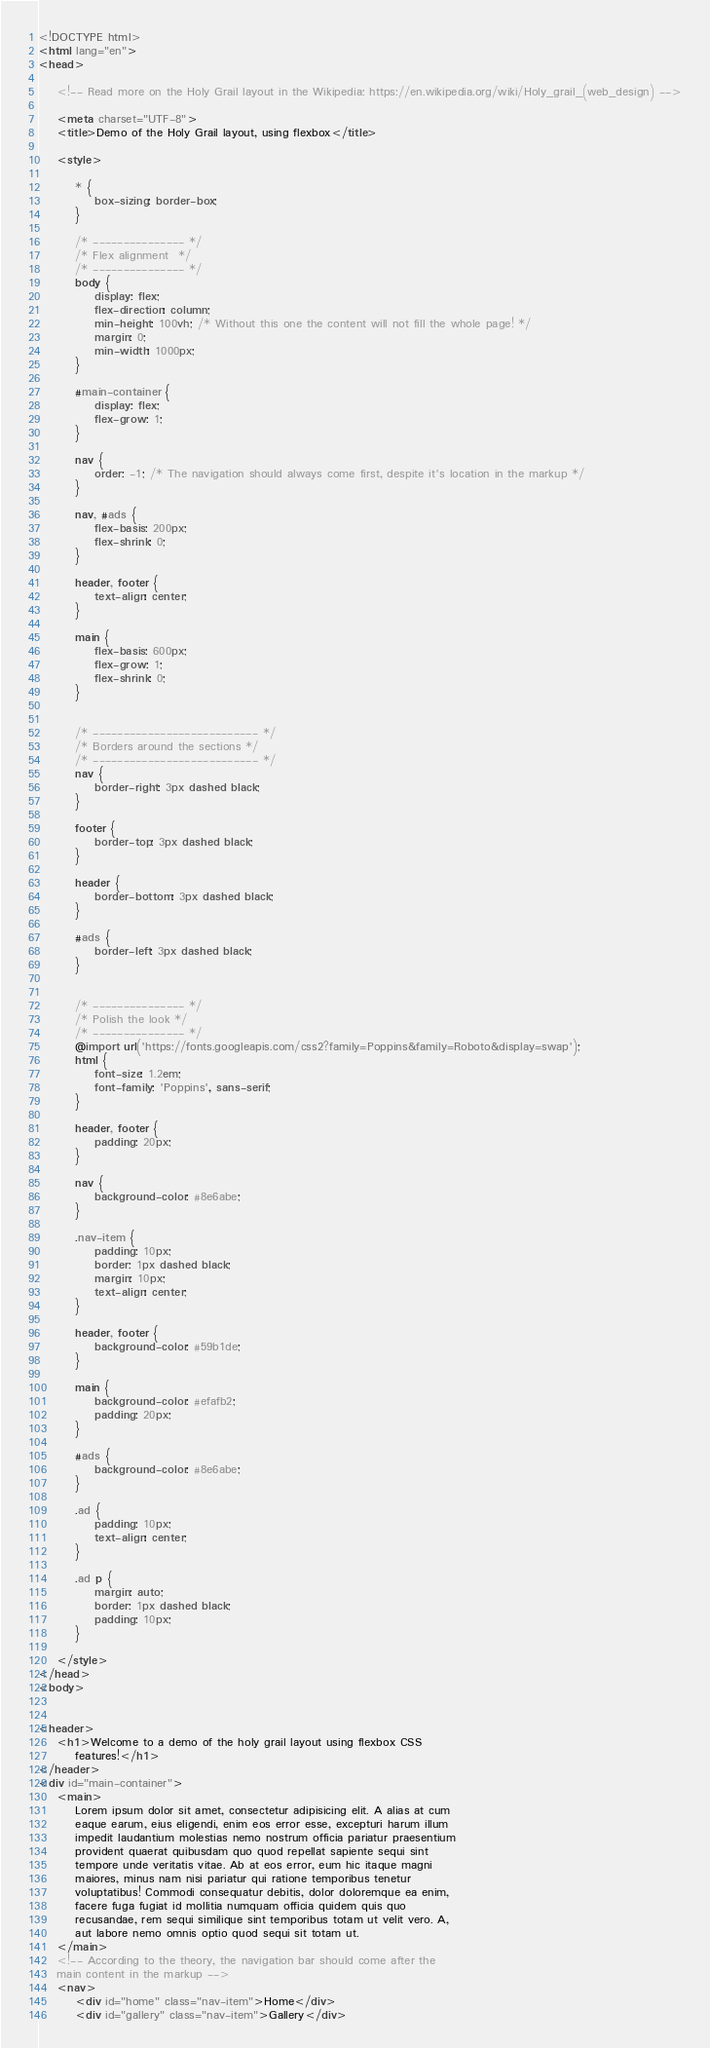Convert code to text. <code><loc_0><loc_0><loc_500><loc_500><_HTML_><!DOCTYPE html>
<html lang="en">
<head>

    <!-- Read more on the Holy Grail layout in the Wikipedia: https://en.wikipedia.org/wiki/Holy_grail_(web_design) -->

    <meta charset="UTF-8">
    <title>Demo of the Holy Grail layout, using flexbox</title>

    <style>

        * {
            box-sizing: border-box;
        }

        /* --------------- */
        /* Flex alignment  */
        /* --------------- */
        body {
            display: flex;
            flex-direction: column;
            min-height: 100vh; /* Without this one the content will not fill the whole page! */
            margin: 0;
            min-width: 1000px;
        }

        #main-container {
            display: flex;
            flex-grow: 1;
        }

        nav {
            order: -1; /* The navigation should always come first, despite it's location in the markup */
        }

        nav, #ads {
            flex-basis: 200px;
            flex-shrink: 0;
        }

        header, footer {
            text-align: center;
        }

        main {
            flex-basis: 600px;
            flex-grow: 1;
            flex-shrink: 0;
        }


        /* --------------------------- */
        /* Borders around the sections */
        /* --------------------------- */
        nav {
            border-right: 3px dashed black;
        }

        footer {
            border-top: 3px dashed black;
        }

        header {
            border-bottom: 3px dashed black;
        }

        #ads {
            border-left: 3px dashed black;
        }


        /* --------------- */
        /* Polish the look */
        /* --------------- */
        @import url('https://fonts.googleapis.com/css2?family=Poppins&family=Roboto&display=swap');
        html {
            font-size: 1.2em;
            font-family: 'Poppins', sans-serif;
        }

        header, footer {
            padding: 20px;
        }

        nav {
            background-color: #8e6abe;
        }

        .nav-item {
            padding: 10px;
            border: 1px dashed black;
            margin: 10px;
            text-align: center;
        }

        header, footer {
            background-color: #59b1de;
        }

        main {
            background-color: #efafb2;
            padding: 20px;
        }

        #ads {
            background-color: #8e6abe;
        }

        .ad {
            padding: 10px;
            text-align: center;
        }

        .ad p {
            margin: auto;
            border: 1px dashed black;
            padding: 10px;
        }

    </style>
</head>
<body>


<header>
    <h1>Welcome to a demo of the holy grail layout using flexbox CSS
        features!</h1>
</header>
<div id="main-container">
    <main>
        Lorem ipsum dolor sit amet, consectetur adipisicing elit. A alias at cum
        eaque earum, eius eligendi, enim eos error esse, excepturi harum illum
        impedit laudantium molestias nemo nostrum officia pariatur praesentium
        provident quaerat quibusdam quo quod repellat sapiente sequi sint
        tempore unde veritatis vitae. Ab at eos error, eum hic itaque magni
        maiores, minus nam nisi pariatur qui ratione temporibus tenetur
        voluptatibus! Commodi consequatur debitis, dolor doloremque ea enim,
        facere fuga fugiat id mollitia numquam officia quidem quis quo
        recusandae, rem sequi similique sint temporibus totam ut velit vero. A,
        aut labore nemo omnis optio quod sequi sit totam ut.
    </main>
    <!-- According to the theory, the navigation bar should come after the
    main content in the markup -->
    <nav>
        <div id="home" class="nav-item">Home</div>
        <div id="gallery" class="nav-item">Gallery</div></code> 